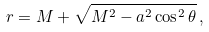Convert formula to latex. <formula><loc_0><loc_0><loc_500><loc_500>r = M + \sqrt { M ^ { 2 } - a ^ { 2 } \cos ^ { 2 } \theta } \, ,</formula> 